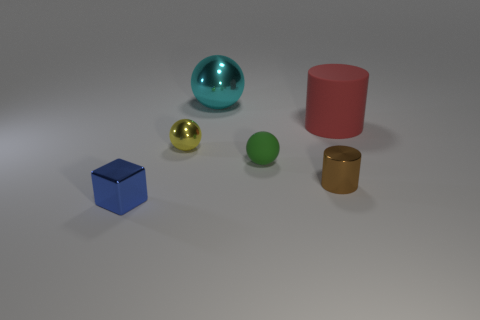Which object stands out the most, and why? The large turquoise blue sphere stands out the most due to its size, shiny surface, and the light reflection that makes it eye-catching compared to the more matte finishes of the other objects. 